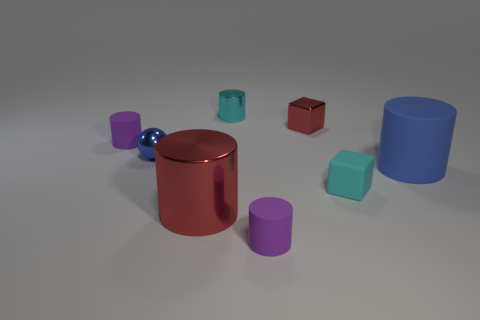Is the number of blue shiny balls greater than the number of red shiny things?
Provide a short and direct response. No. There is a small cylinder left of the red object in front of the purple cylinder behind the cyan matte thing; what color is it?
Provide a short and direct response. Purple. There is a tiny block that is the same material as the ball; what is its color?
Ensure brevity in your answer.  Red. Is there anything else that is the same size as the blue matte cylinder?
Make the answer very short. Yes. How many things are either cylinders that are behind the large blue thing or things to the left of the cyan cylinder?
Offer a very short reply. 4. Do the purple object that is to the left of the small cyan metallic cylinder and the red object that is behind the large shiny object have the same size?
Provide a short and direct response. Yes. There is a large rubber object that is the same shape as the tiny cyan metallic object; what is its color?
Give a very brief answer. Blue. Is there any other thing that has the same shape as the big red object?
Provide a short and direct response. Yes. Is the number of purple objects in front of the small blue object greater than the number of tiny purple cylinders that are behind the small shiny cube?
Provide a succinct answer. Yes. There is a purple rubber cylinder that is in front of the small sphere in front of the purple matte cylinder on the left side of the tiny cyan cylinder; what is its size?
Give a very brief answer. Small. 